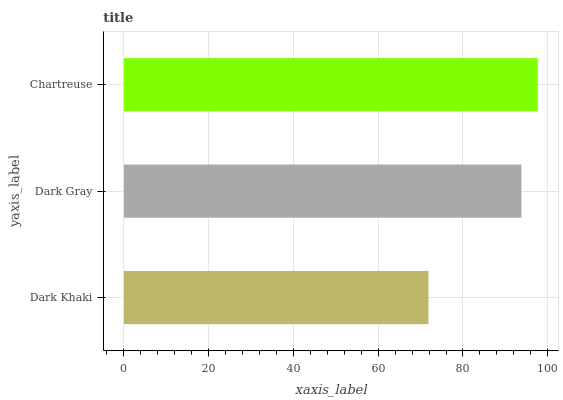Is Dark Khaki the minimum?
Answer yes or no. Yes. Is Chartreuse the maximum?
Answer yes or no. Yes. Is Dark Gray the minimum?
Answer yes or no. No. Is Dark Gray the maximum?
Answer yes or no. No. Is Dark Gray greater than Dark Khaki?
Answer yes or no. Yes. Is Dark Khaki less than Dark Gray?
Answer yes or no. Yes. Is Dark Khaki greater than Dark Gray?
Answer yes or no. No. Is Dark Gray less than Dark Khaki?
Answer yes or no. No. Is Dark Gray the high median?
Answer yes or no. Yes. Is Dark Gray the low median?
Answer yes or no. Yes. Is Dark Khaki the high median?
Answer yes or no. No. Is Dark Khaki the low median?
Answer yes or no. No. 